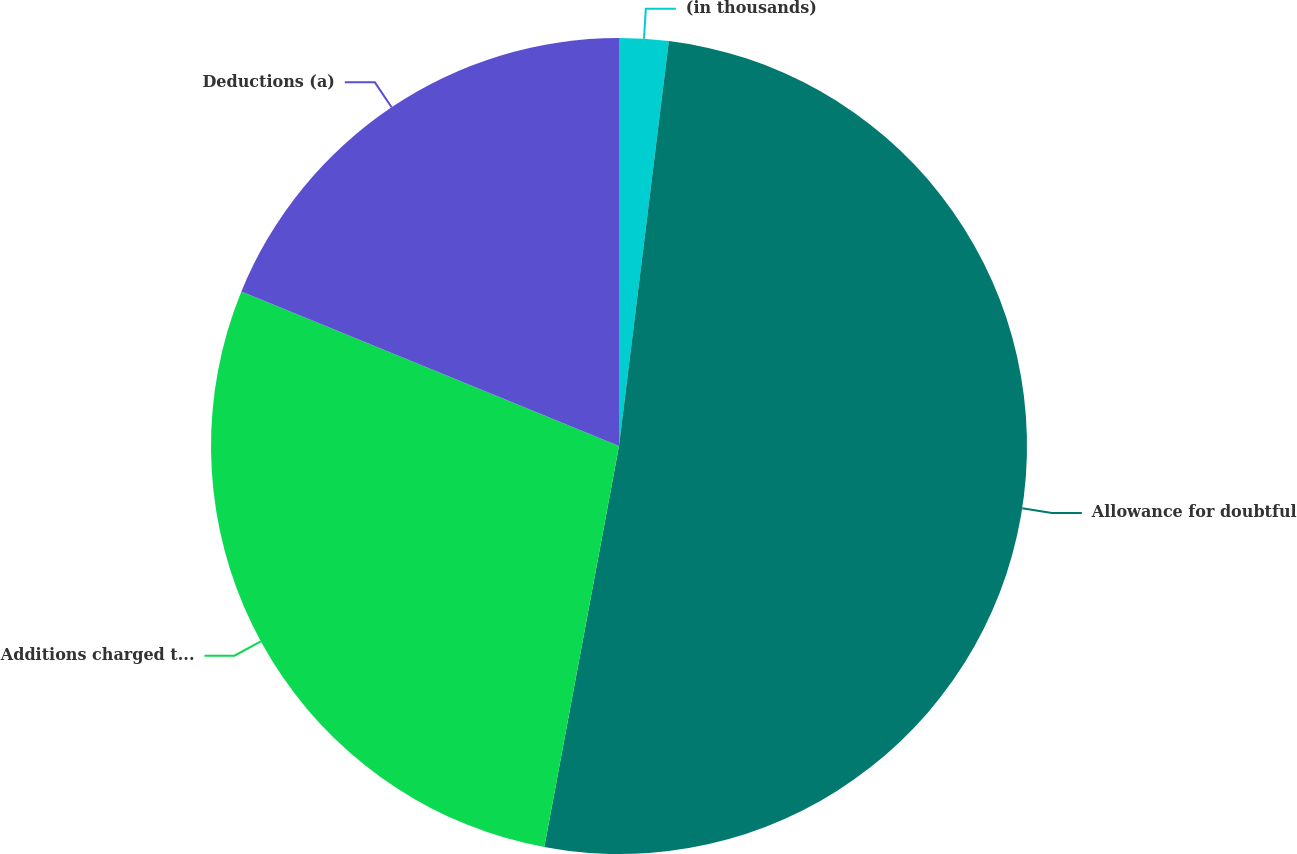Convert chart to OTSL. <chart><loc_0><loc_0><loc_500><loc_500><pie_chart><fcel>(in thousands)<fcel>Allowance for doubtful<fcel>Additions charged to costs and<fcel>Deductions (a)<nl><fcel>1.95%<fcel>50.98%<fcel>28.25%<fcel>18.82%<nl></chart> 